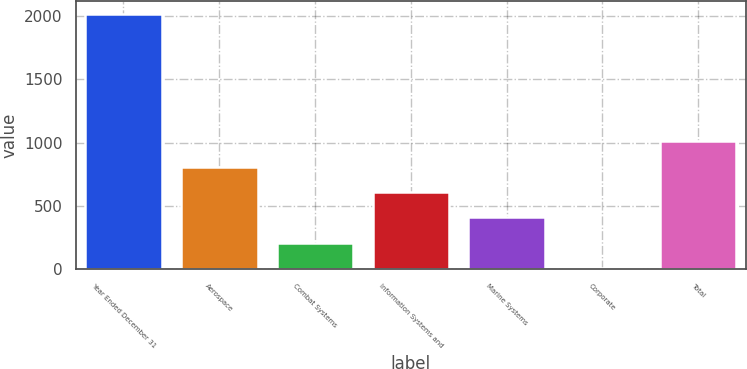<chart> <loc_0><loc_0><loc_500><loc_500><bar_chart><fcel>Year Ended December 31<fcel>Aerospace<fcel>Combat Systems<fcel>Information Systems and<fcel>Marine Systems<fcel>Corporate<fcel>Total<nl><fcel>2015<fcel>810.2<fcel>207.8<fcel>609.4<fcel>408.6<fcel>7<fcel>1011<nl></chart> 